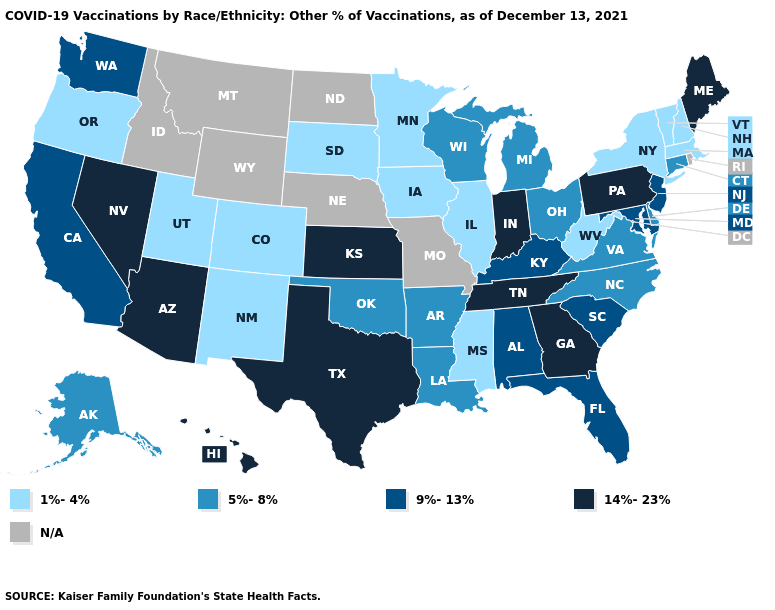Does Pennsylvania have the lowest value in the Northeast?
Short answer required. No. Name the states that have a value in the range 9%-13%?
Write a very short answer. Alabama, California, Florida, Kentucky, Maryland, New Jersey, South Carolina, Washington. What is the lowest value in the USA?
Answer briefly. 1%-4%. Name the states that have a value in the range 1%-4%?
Keep it brief. Colorado, Illinois, Iowa, Massachusetts, Minnesota, Mississippi, New Hampshire, New Mexico, New York, Oregon, South Dakota, Utah, Vermont, West Virginia. What is the value of Nevada?
Short answer required. 14%-23%. What is the value of Nebraska?
Keep it brief. N/A. Which states hav the highest value in the West?
Keep it brief. Arizona, Hawaii, Nevada. How many symbols are there in the legend?
Concise answer only. 5. What is the lowest value in states that border Tennessee?
Write a very short answer. 1%-4%. Does the first symbol in the legend represent the smallest category?
Give a very brief answer. Yes. Name the states that have a value in the range 9%-13%?
Keep it brief. Alabama, California, Florida, Kentucky, Maryland, New Jersey, South Carolina, Washington. Does the map have missing data?
Short answer required. Yes. 